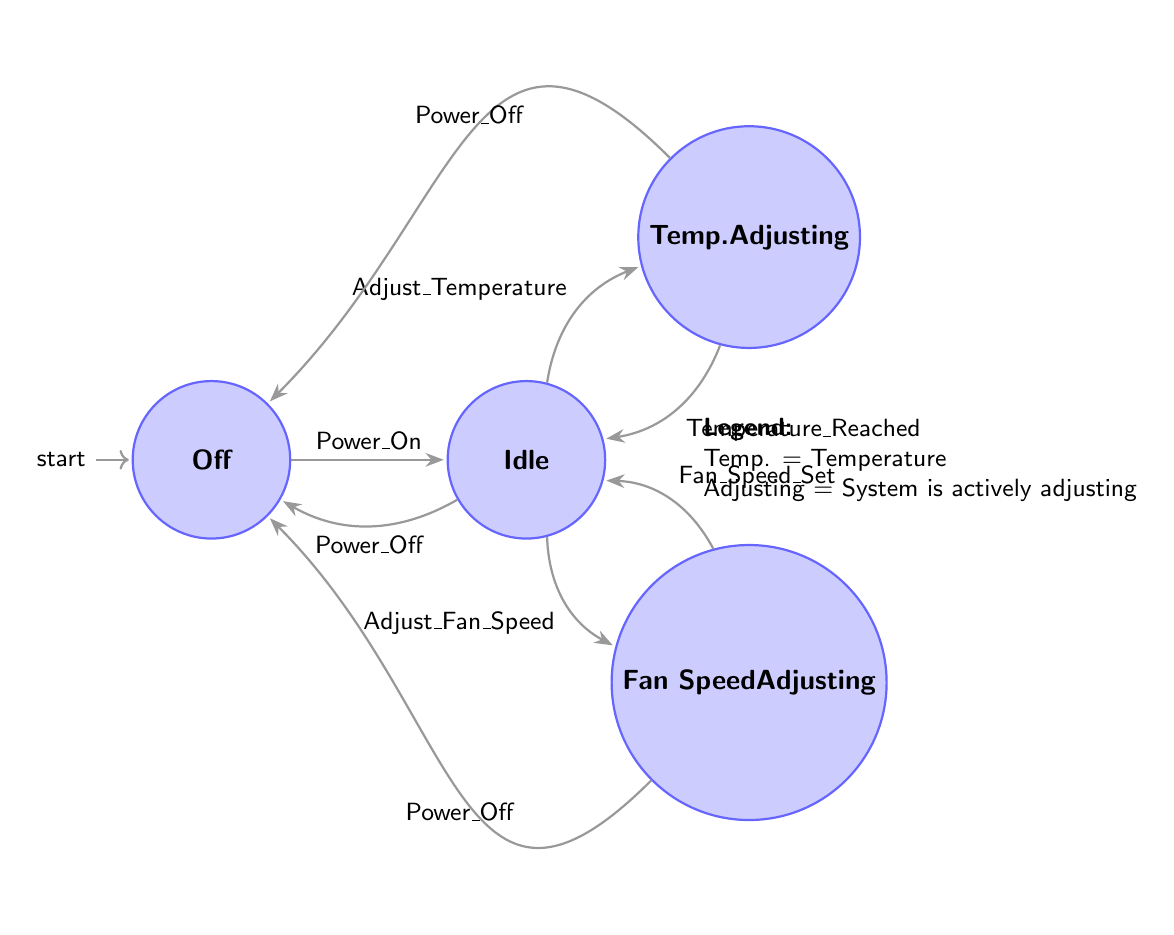What is the initial state of the climate control system? The diagram indicates that the initial state is Off, as it is the state from which all transitions begin.
Answer: Off How many states are present in the system? The diagram lists four distinct states: Off, Idle, Temperature Adjusting, and Fan Speed Adjusting. Therefore, the total count is four states.
Answer: 4 What action transitions the system from Idle to Temperature Adjusting? The transition from Idle to Temperature Adjusting is accomplished by the action Adjust Temperature, which is depicted as a direct connection between these two states.
Answer: Adjust Temperature If the system is in Temperature Adjusting, what action can lead back to Off? The action Power Off allows the system to transition from Temperature Adjusting directly to Off, indicating that the climate control system can be turned off from that state.
Answer: Power Off Which state indicates the system is not actively modifying the climate? The state Idle signifies that the system is powered on but not actively modifying the climate, as described in the diagram.
Answer: Idle What happens after the fan speed is set? After the fan speed is set in the Fan Speed Adjusting state, the system transitions back to the Idle state, indicating that the adjustment has been completed.
Answer: Idle From the Idle state, how many possible actions can lead to a different state? From the Idle state, there are three possible actions: Adjust Temperature, Adjust Fan Speed, and Power Off, which can lead to either Temperature Adjusting, Fan Speed Adjusting, or Off state respectively.
Answer: 3 If the system is currently on, what is one action that can turn it off? The action Power Off can turn the system off from any active state, including Idle, Temperature Adjusting or Fan Speed Adjusting, by directly transitioning to the Off state.
Answer: Power Off Which state maintains the system's operation without modification? The Idle state maintains operation without modification, as it indicates that the system is powered on but not in an active adjustment phase for either temperature or fan speed.
Answer: Idle 